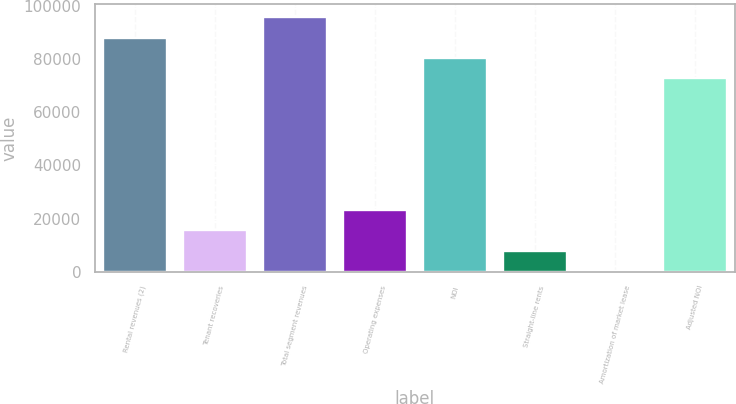Convert chart. <chart><loc_0><loc_0><loc_500><loc_500><bar_chart><fcel>Rental revenues (2)<fcel>Tenant recoveries<fcel>Total segment revenues<fcel>Operating expenses<fcel>NOI<fcel>Straight-line rents<fcel>Amortization of market lease<fcel>Adjusted NOI<nl><fcel>88092.8<fcel>15705.8<fcel>95772.2<fcel>23385.2<fcel>80413.4<fcel>8026.4<fcel>347<fcel>72734<nl></chart> 